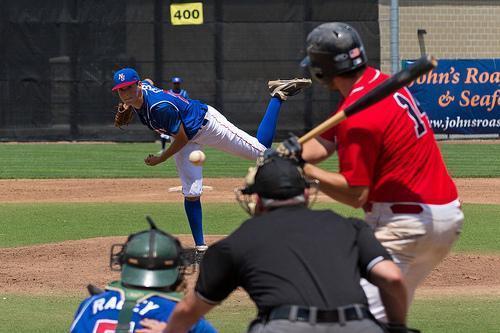How many player that hitting the ball?
Give a very brief answer. 1. 